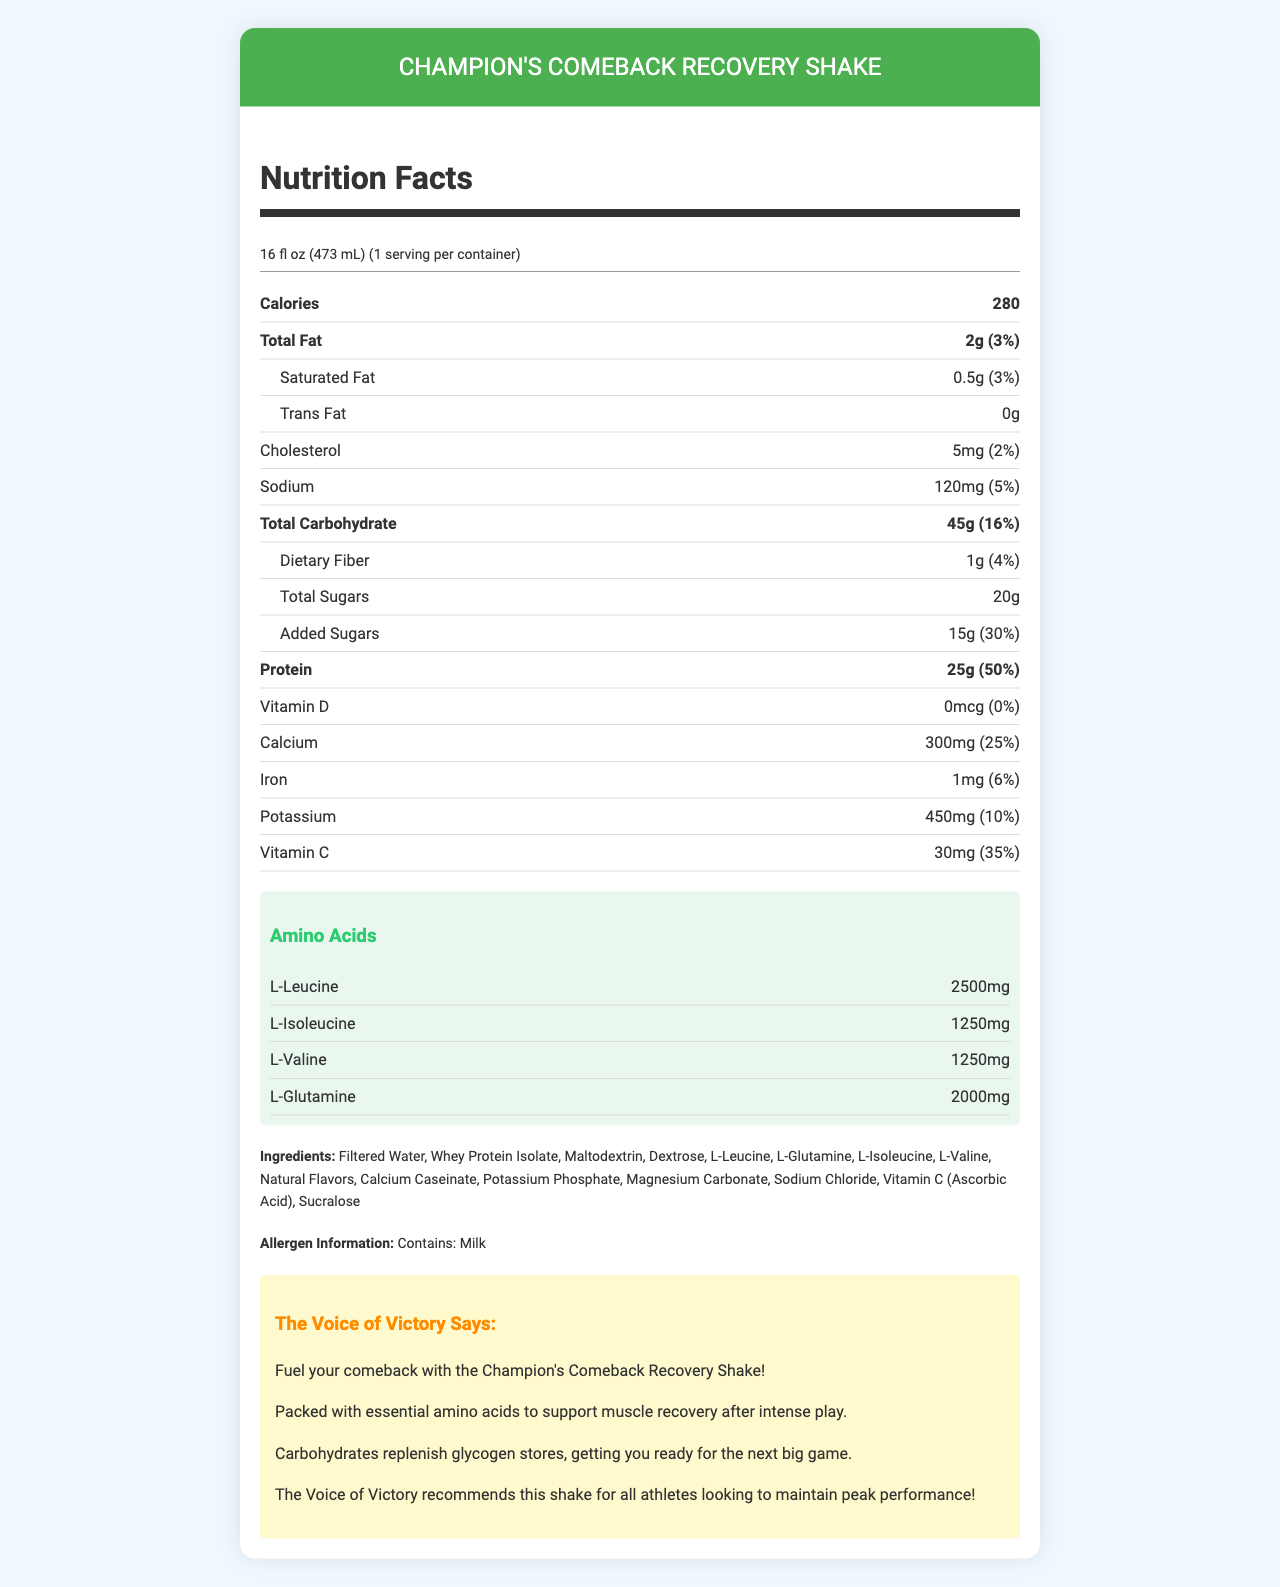how many calories are in a serving of Champion's Comeback Recovery Shake? The document lists "Calories" as 280 in the "Nutrition Facts" section.
Answer: 280 what is the serving size for the recovery shake? The "servingSize" is mentioned as 16 fl oz (473 mL).
Answer: 16 fl oz (473 mL) how much protein does one serving contain? Under "Protein," the amount is specified as 25g.
Answer: 25g what are the main nutrients that contribute to muscle recovery in the shake? The document mentions that the shake is packed with essential amino acids and contains 25g of protein to support muscle recovery.
Answer: amino acids and protein how much sodium is in one serving? The "Sodium" content is specified as 120mg.
Answer: 120mg what is the daily value percentage of calcium in the shake? The calcium daily value percentage is listed as 25%.
Answer: 25% which amino acid has the highest amount per serving? The shake contains 2500mg of L-Leucine, which is the highest among the listed amino acids.
Answer: L-Leucine does the shake contain any added sugars? If yes, how much? The document notes 15g of "Added Sugars."
Answer: Yes, 15g what allergen is mentioned in the recovery shake? The "allergenInfo" section states that the shake contains milk.
Answer: Milk does the shake contain any trans fat? The "transFat" content is listed as 0g.
Answer: No what is the main purpose of Champion's Comeback Recovery Shake? A. Weight loss B. Energy boost C. Muscle recovery D. Heart health The commentator notes indicate that the shake is designed to support muscle recovery.
Answer: C what percentage of daily protein intake does one serving fulfill? A. 25% B. 50% C. 75% D. 100% The document states that the protein content is 25g, which equals 50% of the daily value.
Answer: B is there any Vitamin D in the shake? The "Vitamin D" amount is listed as 0mcg with a 0% daily value.
Answer: No are there any artificial flavors in the recovery shake? The document lists "Natural Flavors" as an ingredient, but does not mention artificial flavors.
Answer: Not mentioned summarize the main information presented in the document. The document gives a comprehensive overview of the nutritional profile of the recovery shake, emphasizing its role in muscle recovery, key nutrients, and taste.
Answer: The document provides the nutrition facts for Champion's Comeback Recovery Shake, a post-game drink designed to support muscle recovery with amino acids and carbohydrates. It details serving size, calories, and nutrient content including proteins, fats, carbohydrates, vitamins, and minerals. The shake contains essential amino acids like L-Leucine and L-Glutamine and includes an allergen notice for milk. Commentator notes promote the shake as beneficial for athletes. what type of protein is used in the shake? The ingredient list mentions "Whey Protein Isolate" as one of the main components.
Answer: Whey Protein Isolate 